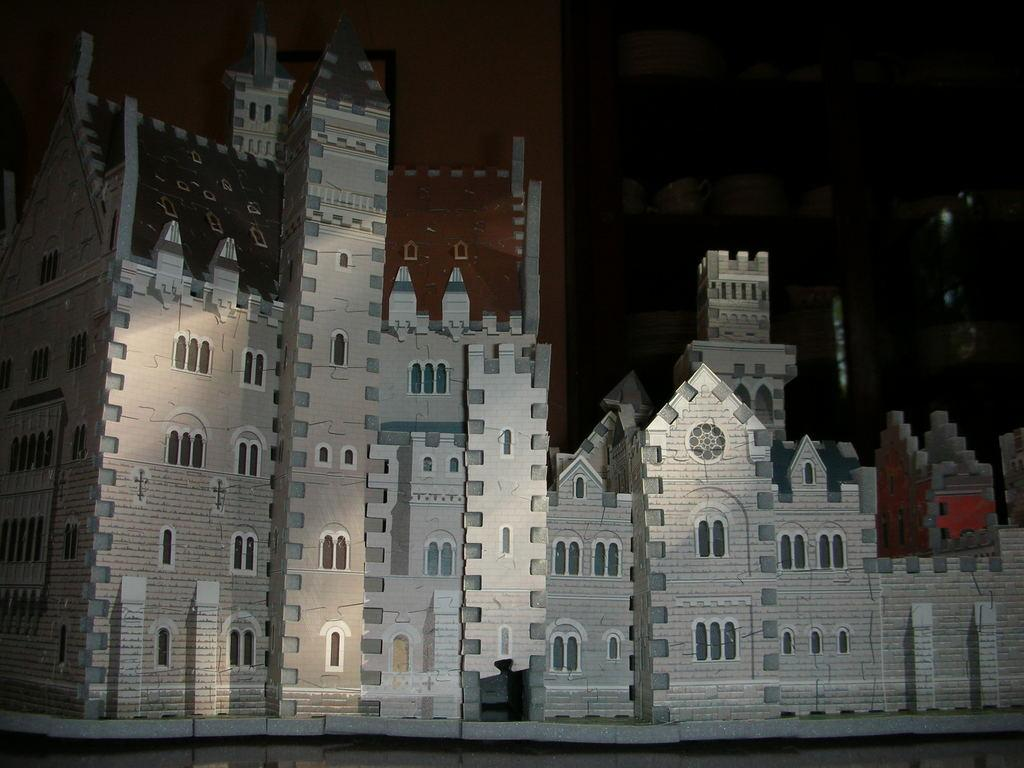What is the main subject of the image? There is a depiction of a building in the image. How would you describe the background of the image? The background of the image is dark. How many hooks are hanging from the building in the image? There are no hooks visible in the image; it only depicts a building. 